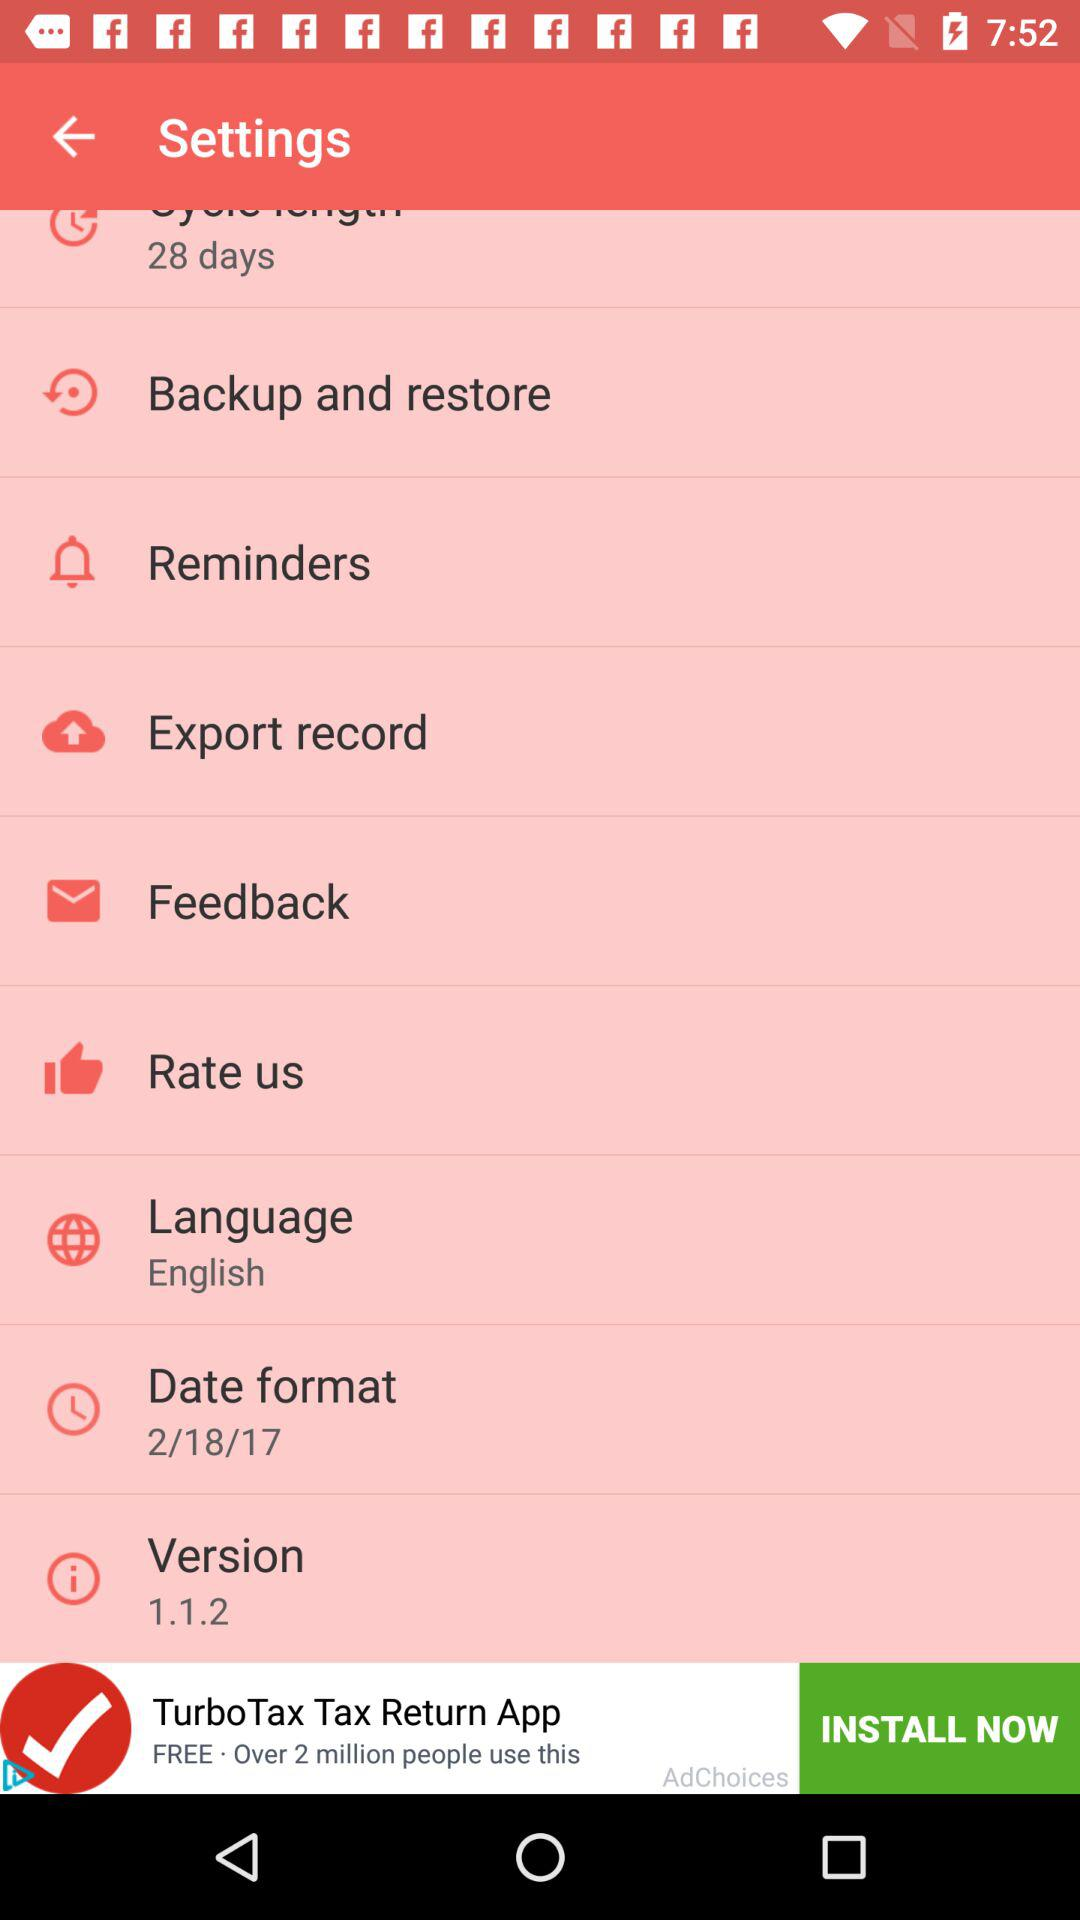What is the selected language? The selected language is "English". 